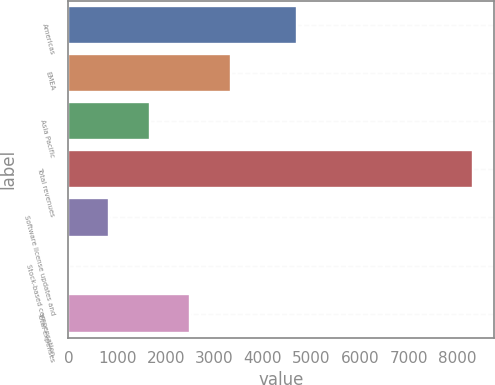Convert chart. <chart><loc_0><loc_0><loc_500><loc_500><bar_chart><fcel>Americas<fcel>EMEA<fcel>Asia Pacific<fcel>Total revenues<fcel>Software license updates and<fcel>Stock-based compensation<fcel>Total expenses<nl><fcel>4698<fcel>3338.2<fcel>1674.6<fcel>8329<fcel>842.8<fcel>11<fcel>2506.4<nl></chart> 